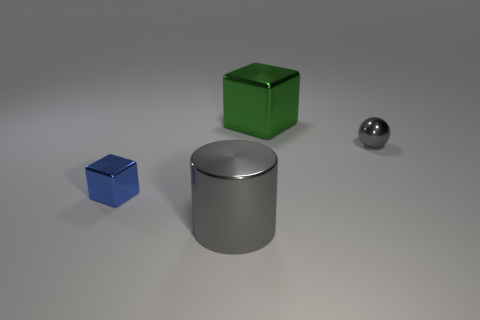Add 1 red rubber spheres. How many objects exist? 5 Subtract all cylinders. How many objects are left? 3 Subtract 1 green cubes. How many objects are left? 3 Subtract all small cubes. Subtract all large green blocks. How many objects are left? 2 Add 1 metal blocks. How many metal blocks are left? 3 Add 2 small blue metallic objects. How many small blue metallic objects exist? 3 